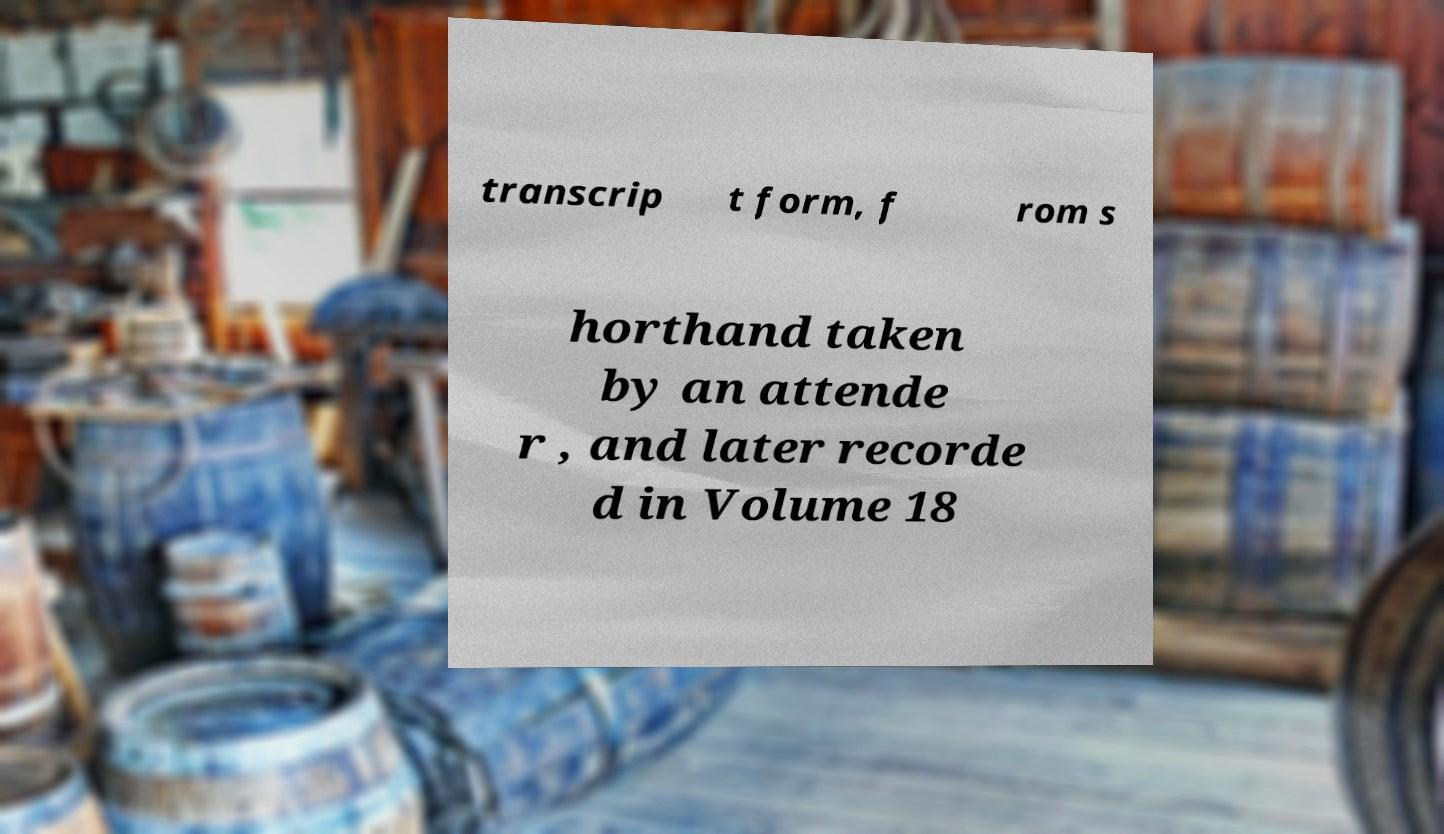I need the written content from this picture converted into text. Can you do that? transcrip t form, f rom s horthand taken by an attende r , and later recorde d in Volume 18 